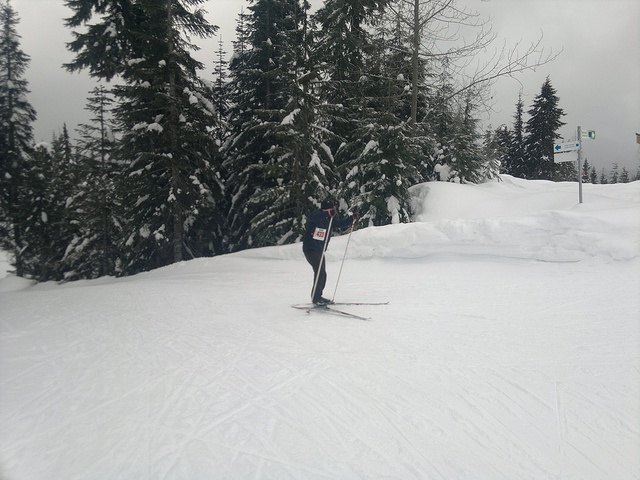Describe the objects in this image and their specific colors. I can see people in lightgray, black, and gray tones and skis in lightgray, darkgray, and gray tones in this image. 